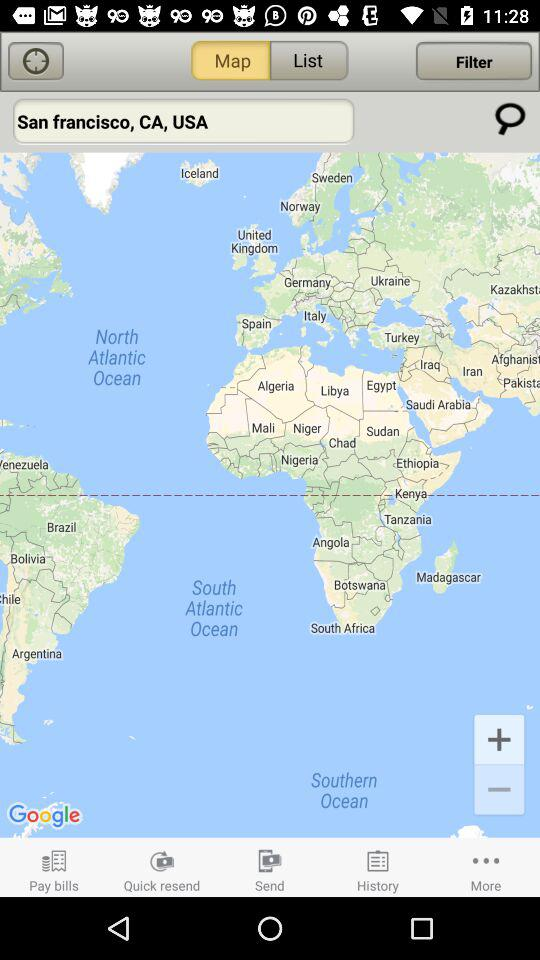What is the location entered in the search box? The entered location is San Francisco, CA, USA. 